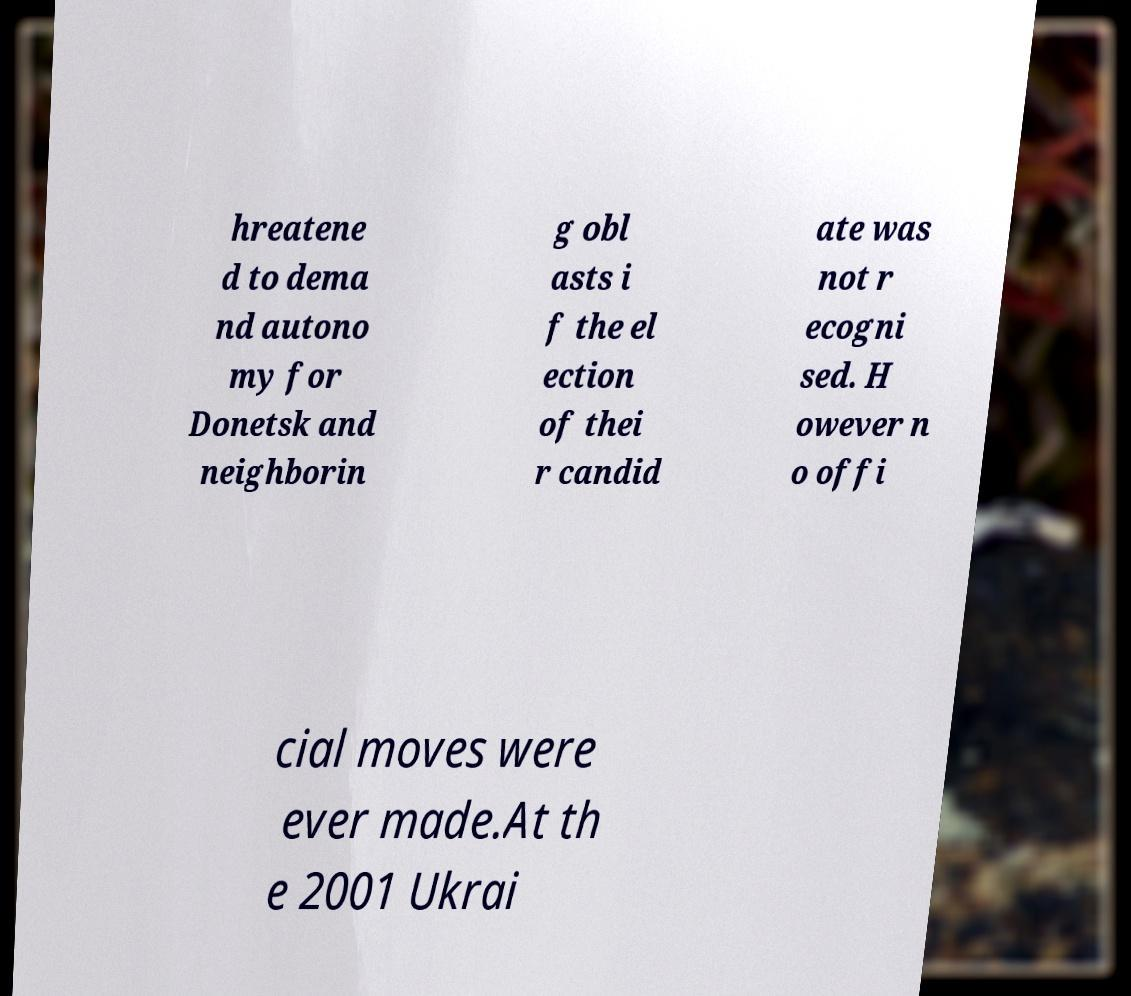What messages or text are displayed in this image? I need them in a readable, typed format. hreatene d to dema nd autono my for Donetsk and neighborin g obl asts i f the el ection of thei r candid ate was not r ecogni sed. H owever n o offi cial moves were ever made.At th e 2001 Ukrai 